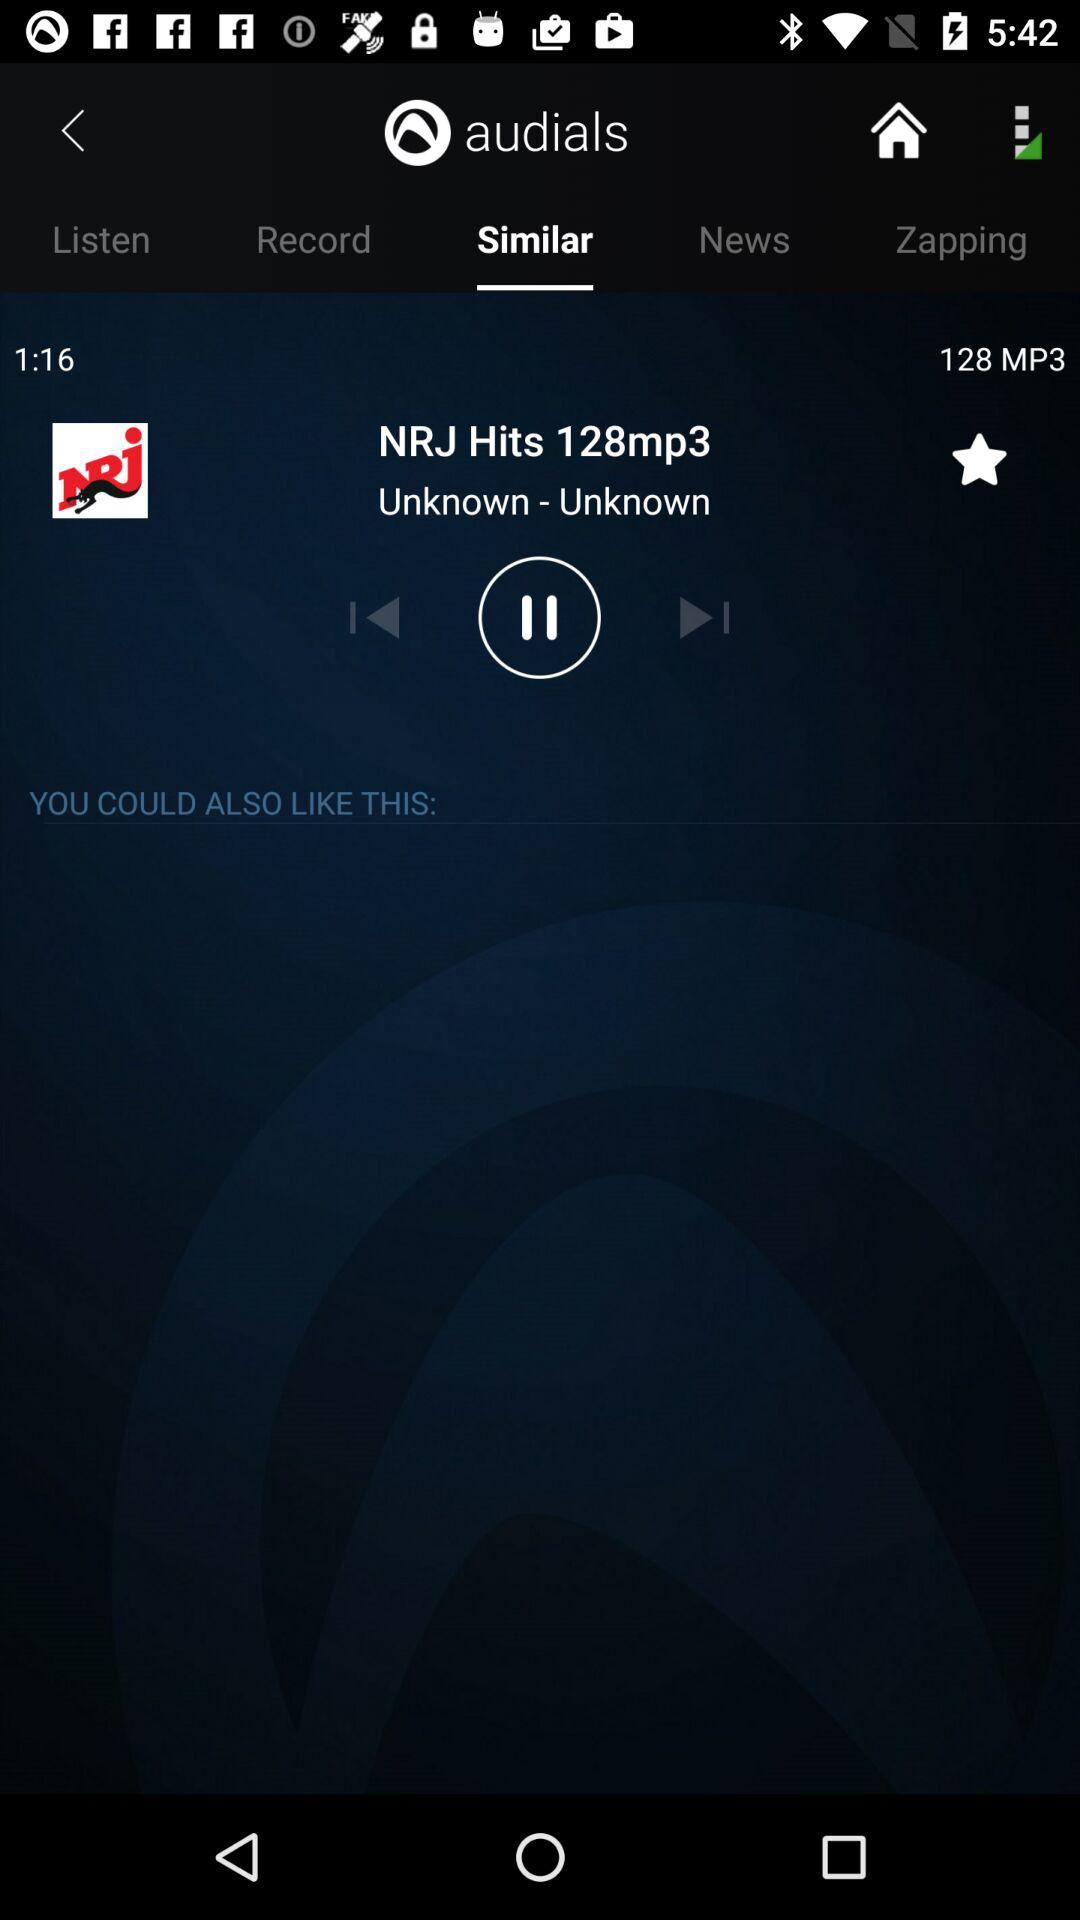Which song is currently playing? The song currently playing is "NRJ Hits 128mp3". 